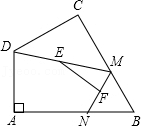First perform reasoning, then finally select the question from the choices in the following format: Answer: xxx.
Question: In quadrilateral ABCD, where angle A = 90°, the length of side AB is 'p' units, and the length of side AD is 'q' units. Let point M and point N be moving points on sides BC and AB respectively (including the endpoints, but point M cannot coincide with point B). Similarly, point E and point F are midpoints of DM and MN respectively. What is the maximum value of the length of EF, denoted as 'z' units?
Choices:
A: 3
B: 2√{3}
C: 4
D: 2 By connecting DN and DB, in right triangle DAB, the length of AB is 'p' units and AD is 'q' units, leading to BD being √{AD^2+AB^2}. Considering E and F are midpoints of DM and MN respectively, EF equals 0.5 × DN. According to the question, DN is maximized when point N coincides with point B, resulting in the maximum value of √{p^2 + q^2}. Thus, the maximum value of EF length is half of √{p^2 + q^2}. Hence, the correct answer is option D.
Answer:D 